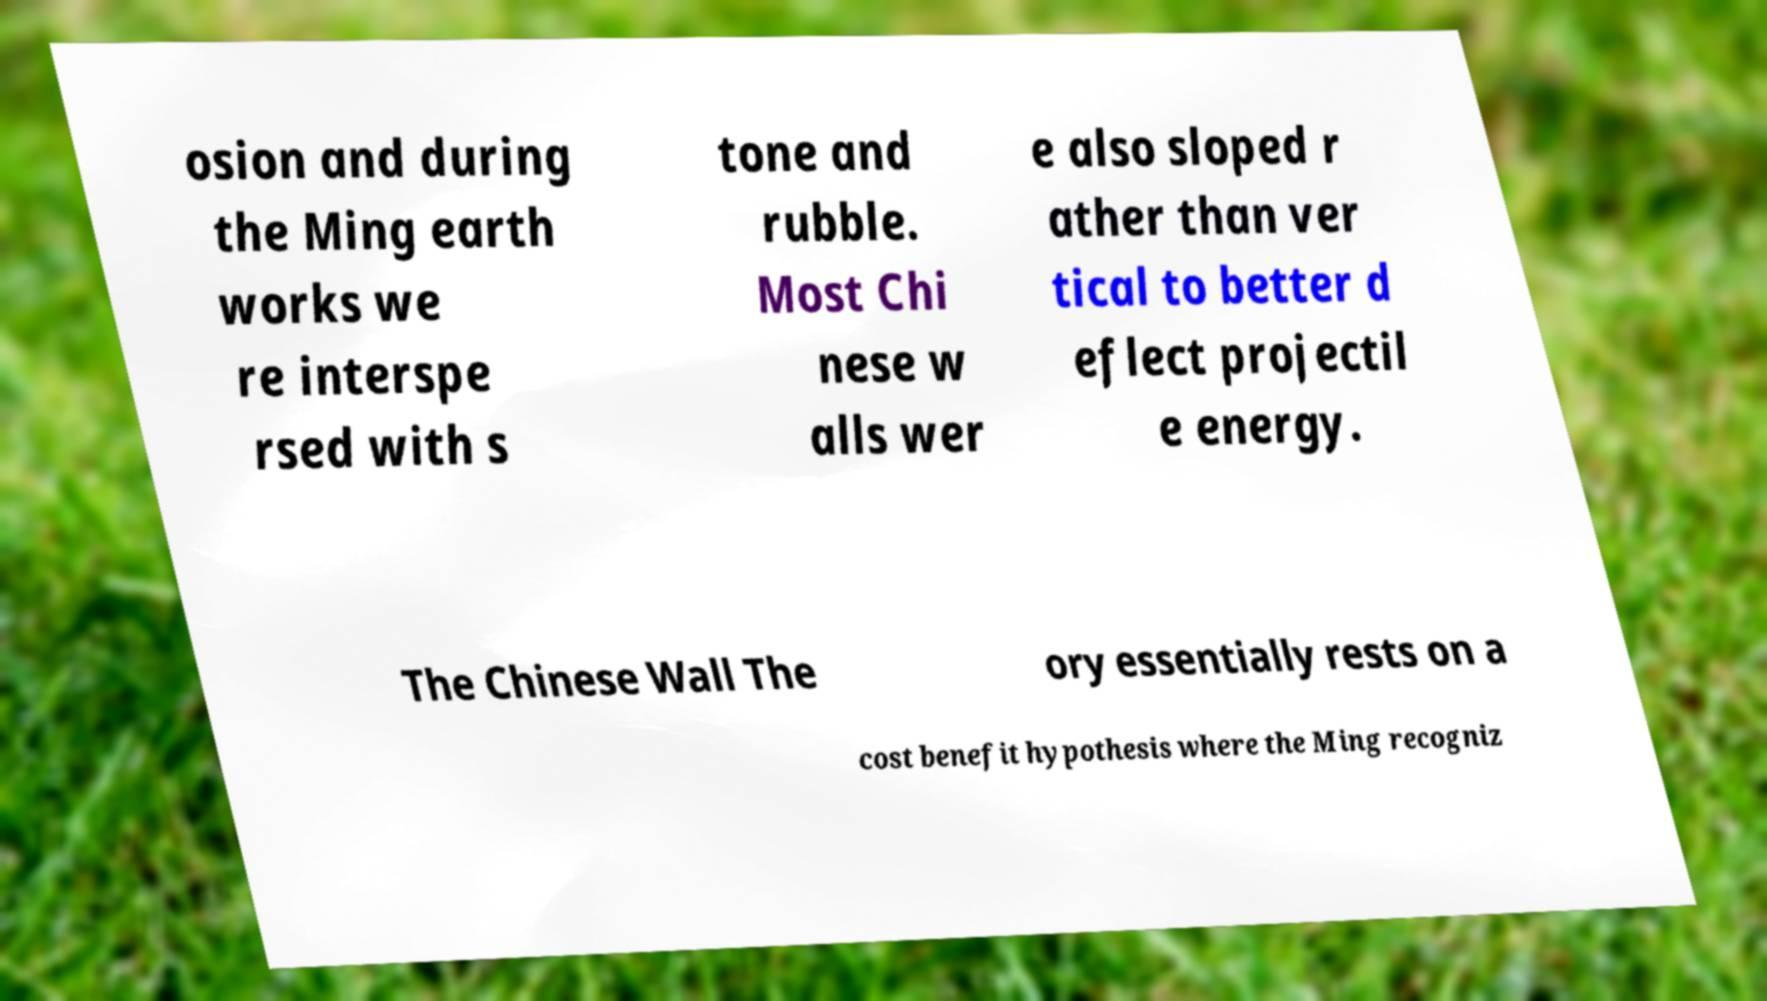I need the written content from this picture converted into text. Can you do that? osion and during the Ming earth works we re interspe rsed with s tone and rubble. Most Chi nese w alls wer e also sloped r ather than ver tical to better d eflect projectil e energy. The Chinese Wall The ory essentially rests on a cost benefit hypothesis where the Ming recogniz 